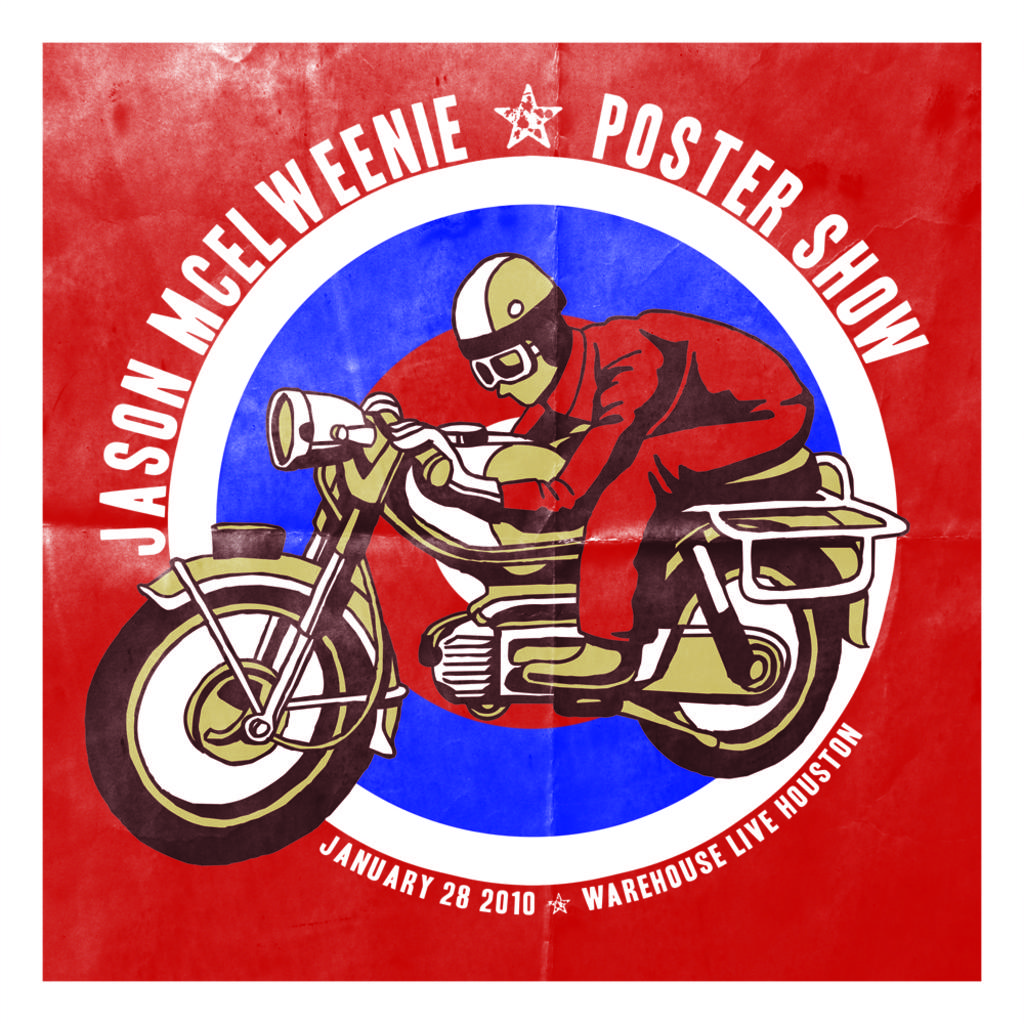What is depicted on the poster in the image? The poster features a person sitting on a bike. What else can be seen on the poster besides the person on the bike? There is text on the poster. What route does the person on the bike take in the image? There is no route depicted in the image; it only shows a person sitting on a bike. What type of map is displayed on the poster? There is no map present on the poster; it features a person sitting on a bike and text. 